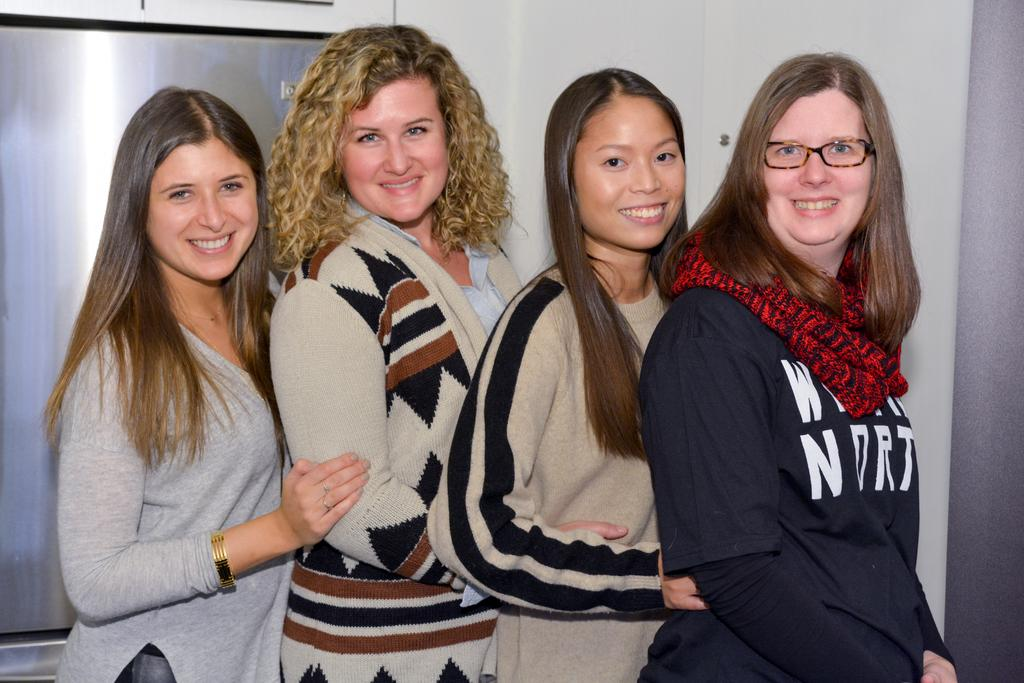What is happening in the middle of the image? There are women standing in the middle of the image. What is the facial expression of the women? The women are smiling. What can be seen in the background of the image? There is a wall in the background of the image. How many children are playing with quartz in the image? There are no children or quartz present in the image. What type of mist can be seen surrounding the women in the image? There is no mist present in the image; the women are standing in a clear environment. 